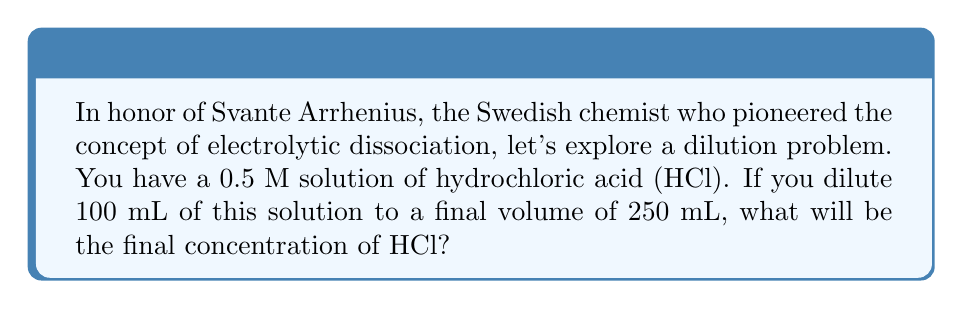Teach me how to tackle this problem. Let's approach this step-by-step using the dilution equation:

1) The dilution equation is:
   $$C_1V_1 = C_2V_2$$
   Where:
   $C_1$ = initial concentration
   $V_1$ = initial volume
   $C_2$ = final concentration (unknown)
   $V_2$ = final volume

2) We know:
   $C_1 = 0.5$ M
   $V_1 = 100$ mL
   $V_2 = 250$ mL

3) Let's substitute these values into the equation:
   $$(0.5 \text{ M})(100 \text{ mL}) = C_2(250 \text{ mL})$$

4) Simplify the left side:
   $$50 \text{ mM⋅mL} = C_2(250 \text{ mL})$$

5) Solve for $C_2$:
   $$C_2 = \frac{50 \text{ mM⋅mL}}{250 \text{ mL}} = 0.2 \text{ M}$$

Therefore, the final concentration of HCl after dilution is 0.2 M.
Answer: 0.2 M 